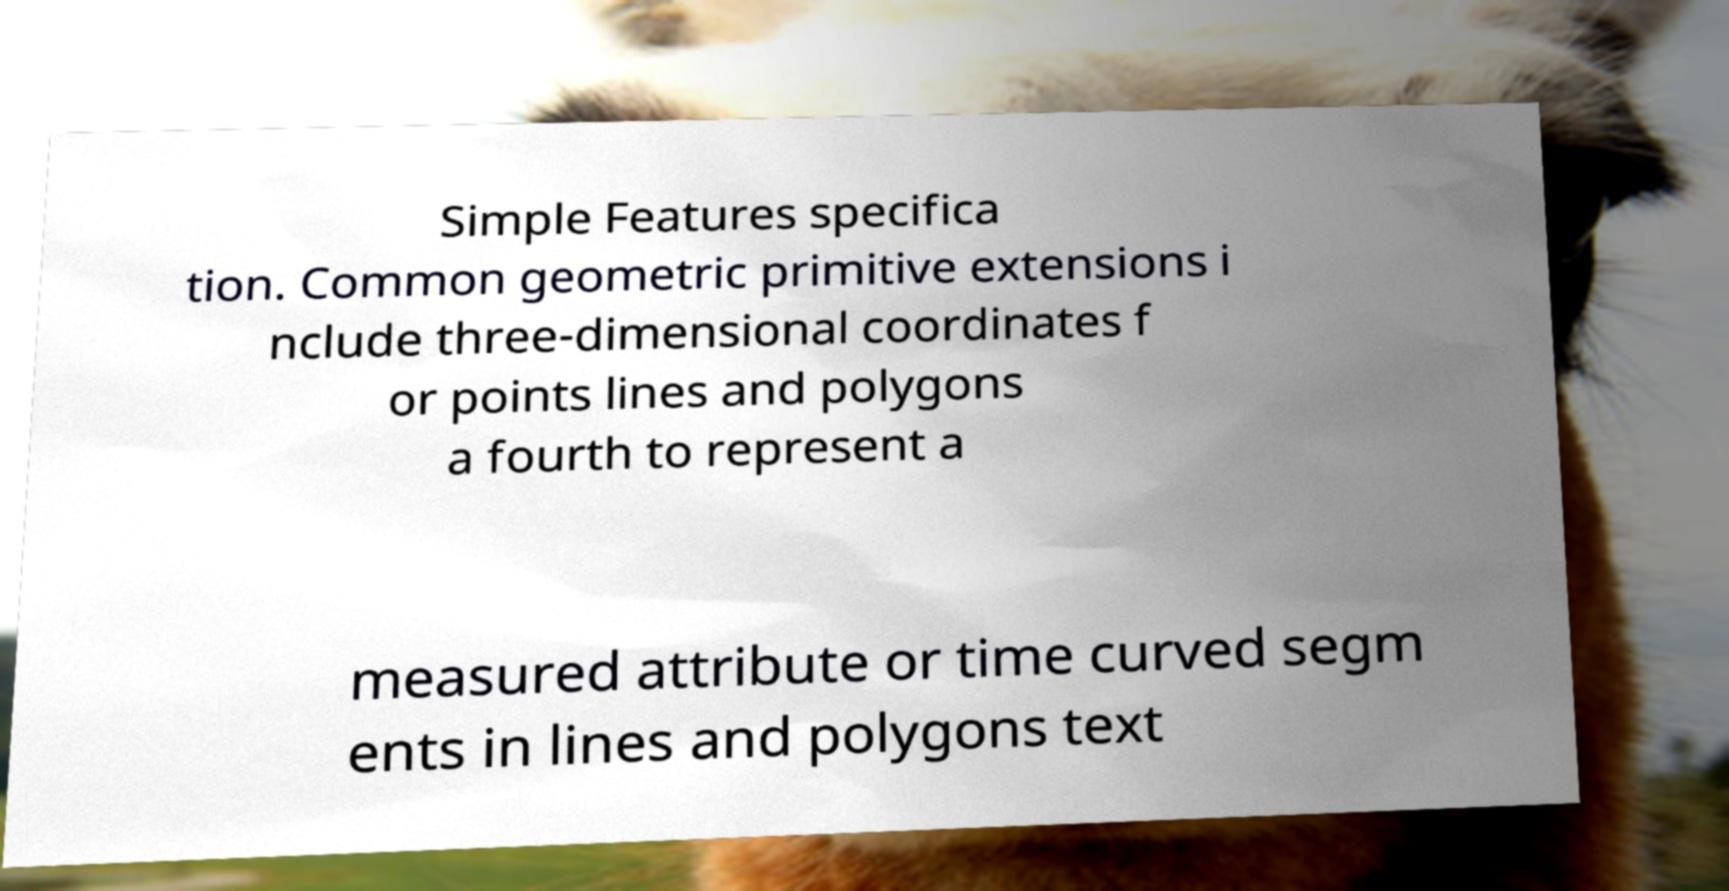What messages or text are displayed in this image? I need them in a readable, typed format. Simple Features specifica tion. Common geometric primitive extensions i nclude three-dimensional coordinates f or points lines and polygons a fourth to represent a measured attribute or time curved segm ents in lines and polygons text 